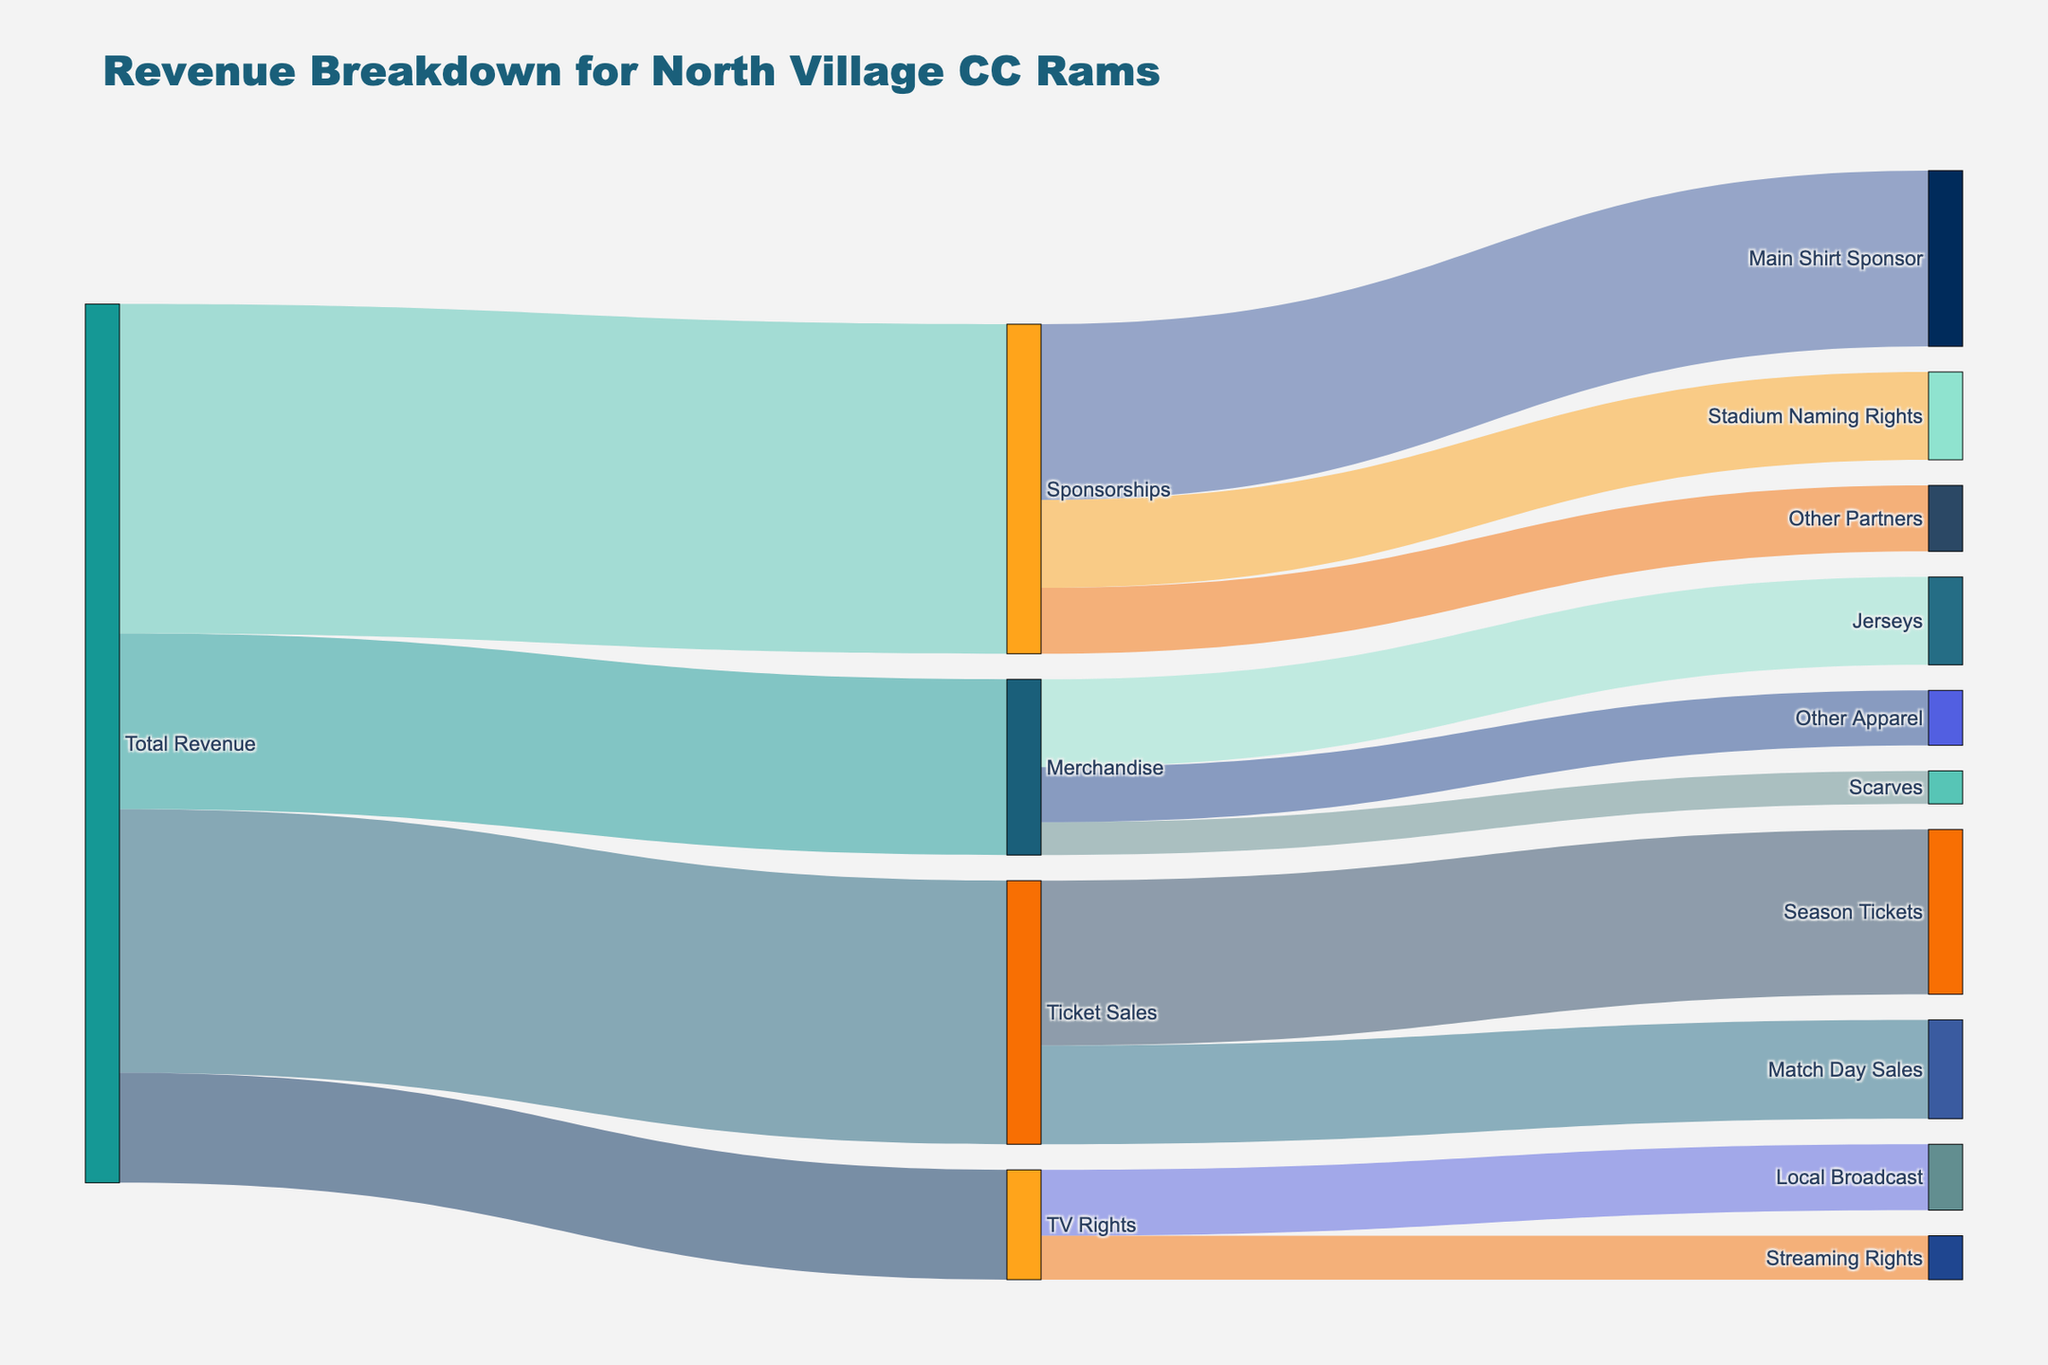What is the total revenue from Ticket Sales? To find this, look at the flow from 'Total Revenue' to 'Ticket Sales'. The diagram shows that 'Ticket Sales' contributes a value of 1,200,000.
Answer: 1,200,000 How much revenue is generated from season tickets? Look at the flow from 'Ticket Sales' to 'Season Tickets'. The diagram shows that 'Season Tickets' contributes a value of 750,000.
Answer: 750,000 Which source has the highest contribution to the total revenue? Comparing all the values from 'Total Revenue' to 'Ticket Sales', ‘Merchandise’, ‘Sponsorships’, and ‘TV Rights’, the highest value is 1,500,000 from 'Sponsorships'.
Answer: Sponsorships What are the combined revenues from Match Day Sales and Other Apparel? Add the value from 'Ticket Sales' to 'Match Day Sales' (450,000) and from 'Merchandise' to 'Other Apparel' (250,000). The combined revenue is 450,000 + 250,000 = 700,000.
Answer: 700,000 How does the revenue from Streaming Rights compare to that from the Local Broadcast? Compare the values from 'TV Rights' to 'Local Broadcast' (300,000) and 'TV Rights' to 'Streaming Rights' (200,000). The revenue from Local Broadcast is higher by 100,000.
Answer: Local Broadcast is higher What is the total revenue from Merchandise? Summing up the contributions to 'Merchandise' from 'Jerseys' (400,000), 'Scarves' (150,000), and 'Other Apparel' (250,000) gives a total of 400,000 + 150,000 + 250,000 = 800,000.
Answer: 800,000 Which category within Sponsorships generates the least revenue? Look at the flows from 'Sponsorships' to its subcategories: 'Main Shirt Sponsor' (800,000), 'Stadium Naming Rights' (400,000), and 'Other Partners' (300,000). The least revenue is from 'Other Partners'.
Answer: Other Partners What percentage of the total revenue does TV Rights represent? The total revenue is 4,000,000. The value of 'TV Rights' is 500,000. Calculate the percentage as (500,000 / 4,000,000) * 100 = 12.5%.
Answer: 12.5% What is the difference in revenue between Main Shirt Sponsor and Stadium Naming Rights? Subtract the value of 'Stadium Naming Rights' (400,000) from 'Main Shirt Sponsor' (800,000). The difference is 800,000 - 400,000 = 400,000.
Answer: 400,000 